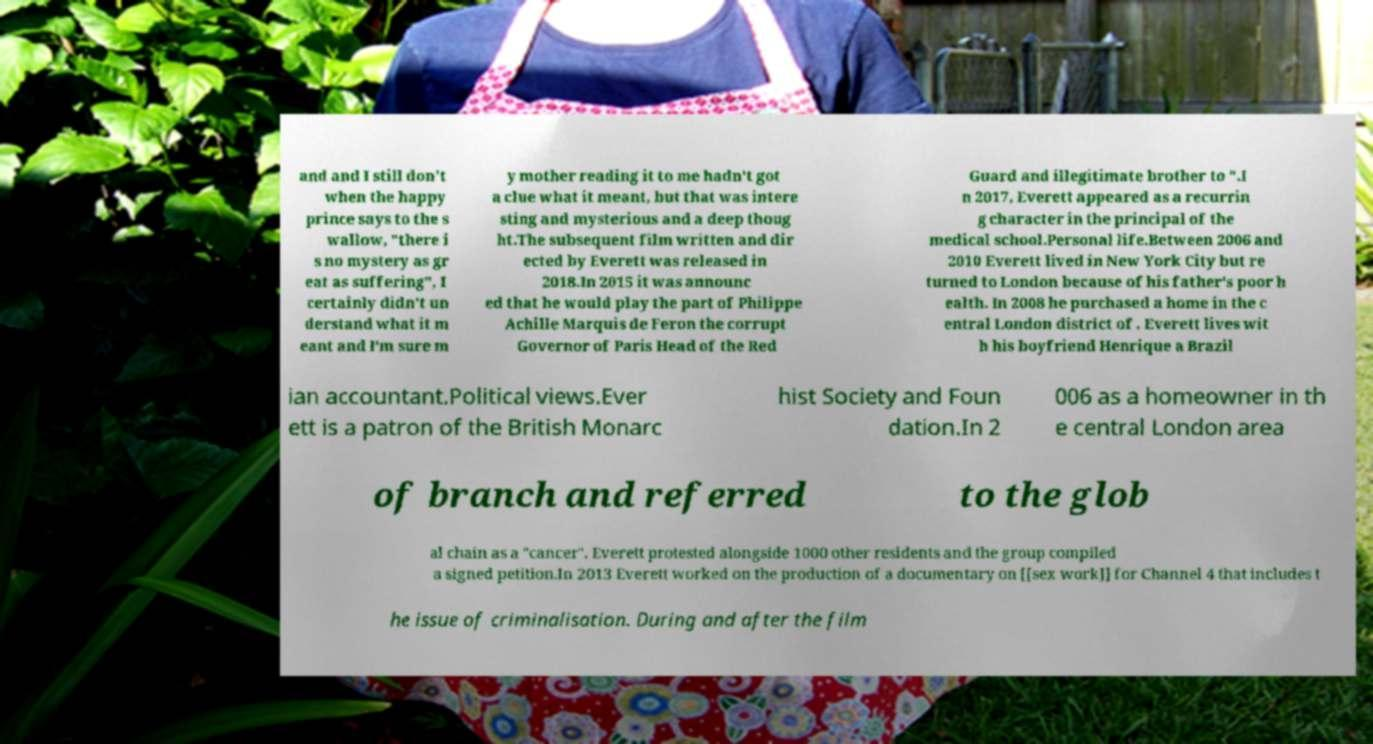There's text embedded in this image that I need extracted. Can you transcribe it verbatim? and and I still don't when the happy prince says to the s wallow, "there i s no mystery as gr eat as suffering", I certainly didn't un derstand what it m eant and I'm sure m y mother reading it to me hadn't got a clue what it meant, but that was intere sting and mysterious and a deep thoug ht.The subsequent film written and dir ected by Everett was released in 2018.In 2015 it was announc ed that he would play the part of Philippe Achille Marquis de Feron the corrupt Governor of Paris Head of the Red Guard and illegitimate brother to ".I n 2017, Everett appeared as a recurrin g character in the principal of the medical school.Personal life.Between 2006 and 2010 Everett lived in New York City but re turned to London because of his father's poor h ealth. In 2008 he purchased a home in the c entral London district of . Everett lives wit h his boyfriend Henrique a Brazil ian accountant.Political views.Ever ett is a patron of the British Monarc hist Society and Foun dation.In 2 006 as a homeowner in th e central London area of branch and referred to the glob al chain as a "cancer". Everett protested alongside 1000 other residents and the group compiled a signed petition.In 2013 Everett worked on the production of a documentary on [[sex work]] for Channel 4 that includes t he issue of criminalisation. During and after the film 